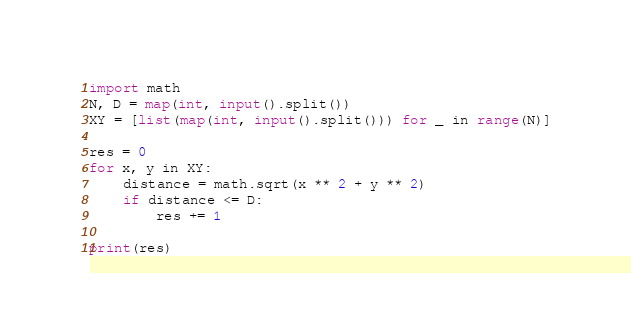Convert code to text. <code><loc_0><loc_0><loc_500><loc_500><_Python_>import math
N, D = map(int, input().split())
XY = [list(map(int, input().split())) for _ in range(N)]

res = 0
for x, y in XY:
    distance = math.sqrt(x ** 2 + y ** 2)
    if distance <= D:
        res += 1

print(res)</code> 